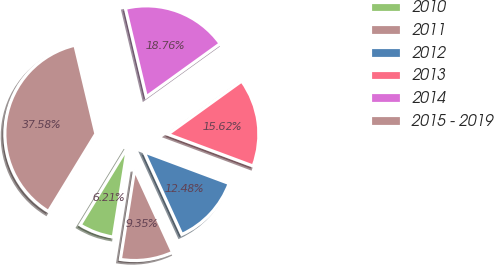Convert chart to OTSL. <chart><loc_0><loc_0><loc_500><loc_500><pie_chart><fcel>2010<fcel>2011<fcel>2012<fcel>2013<fcel>2014<fcel>2015 - 2019<nl><fcel>6.21%<fcel>9.35%<fcel>12.48%<fcel>15.62%<fcel>18.76%<fcel>37.58%<nl></chart> 